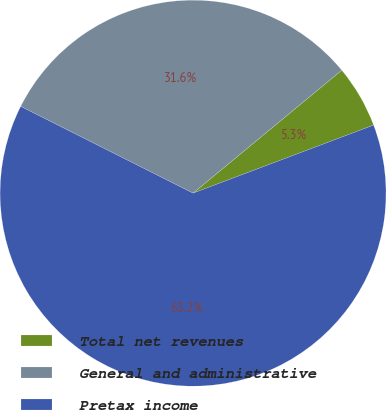Convert chart to OTSL. <chart><loc_0><loc_0><loc_500><loc_500><pie_chart><fcel>Total net revenues<fcel>General and administrative<fcel>Pretax income<nl><fcel>5.26%<fcel>31.58%<fcel>63.16%<nl></chart> 